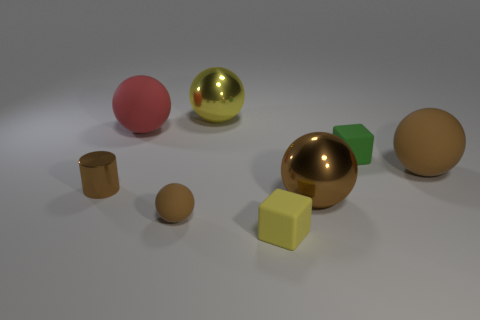Subtract all big yellow spheres. How many spheres are left? 4 Subtract all red cylinders. How many brown balls are left? 3 Subtract all red balls. How many balls are left? 4 Add 1 brown metallic objects. How many objects exist? 9 Subtract all gray balls. Subtract all cyan cylinders. How many balls are left? 5 Subtract all cylinders. How many objects are left? 7 Add 4 large brown matte spheres. How many large brown matte spheres are left? 5 Add 5 small blue things. How many small blue things exist? 5 Subtract 1 yellow cubes. How many objects are left? 7 Subtract all tiny yellow rubber cylinders. Subtract all large brown metallic spheres. How many objects are left? 7 